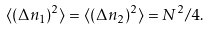Convert formula to latex. <formula><loc_0><loc_0><loc_500><loc_500>\langle ( \Delta n _ { 1 } ) ^ { 2 } \rangle = \langle ( \Delta n _ { 2 } ) ^ { 2 } \rangle = N ^ { 2 } / 4 .</formula> 